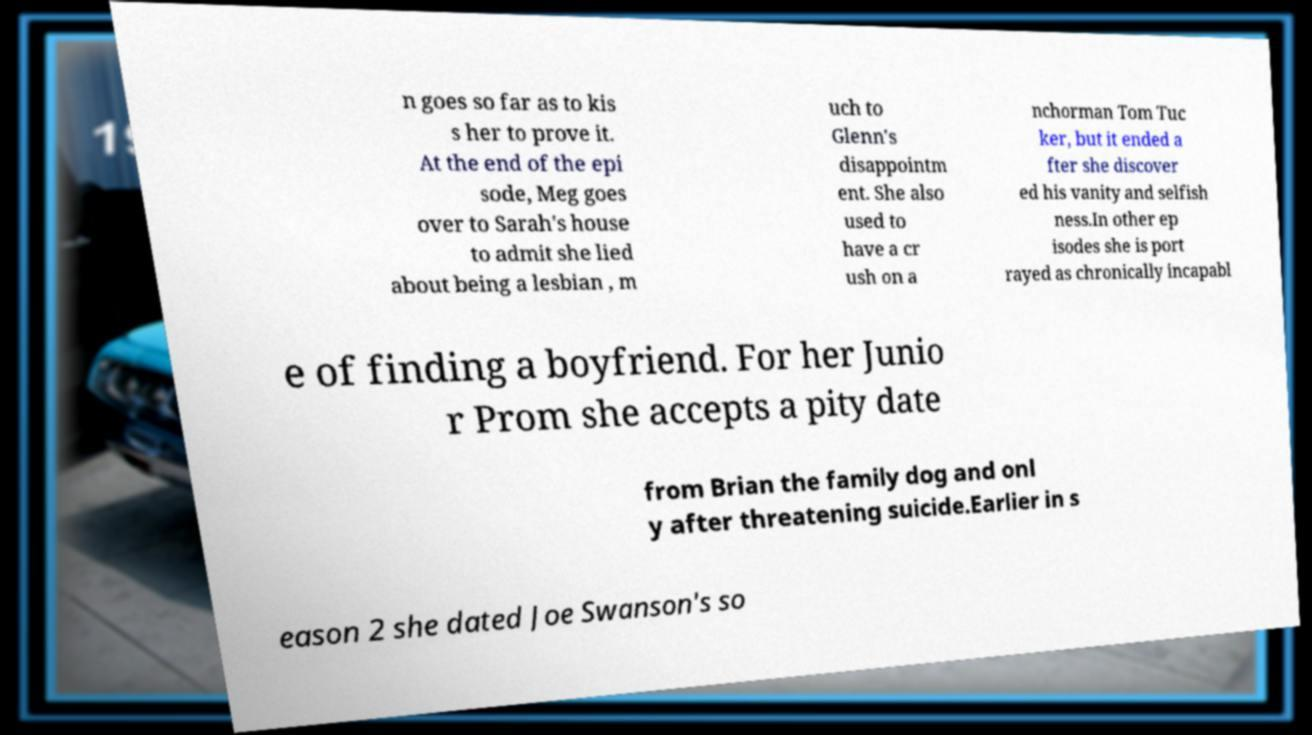I need the written content from this picture converted into text. Can you do that? n goes so far as to kis s her to prove it. At the end of the epi sode, Meg goes over to Sarah's house to admit she lied about being a lesbian , m uch to Glenn's disappointm ent. She also used to have a cr ush on a nchorman Tom Tuc ker, but it ended a fter she discover ed his vanity and selfish ness.In other ep isodes she is port rayed as chronically incapabl e of finding a boyfriend. For her Junio r Prom she accepts a pity date from Brian the family dog and onl y after threatening suicide.Earlier in s eason 2 she dated Joe Swanson's so 